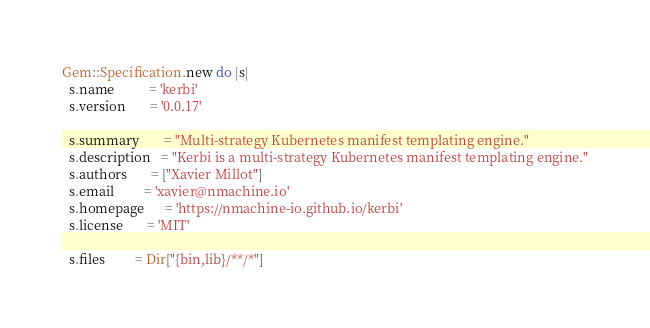<code> <loc_0><loc_0><loc_500><loc_500><_Ruby_>
Gem::Specification.new do |s|
  s.name          = 'kerbi'
  s.version       = '0.0.17'

  s.summary       = "Multi-strategy Kubernetes manifest templating engine."
  s.description   = "Kerbi is a multi-strategy Kubernetes manifest templating engine."
  s.authors       = ["Xavier Millot"]
  s.email         = 'xavier@nmachine.io'
  s.homepage      = 'https://nmachine-io.github.io/kerbi'
  s.license       = 'MIT'

  s.files         = Dir["{bin,lib}/**/*"]</code> 